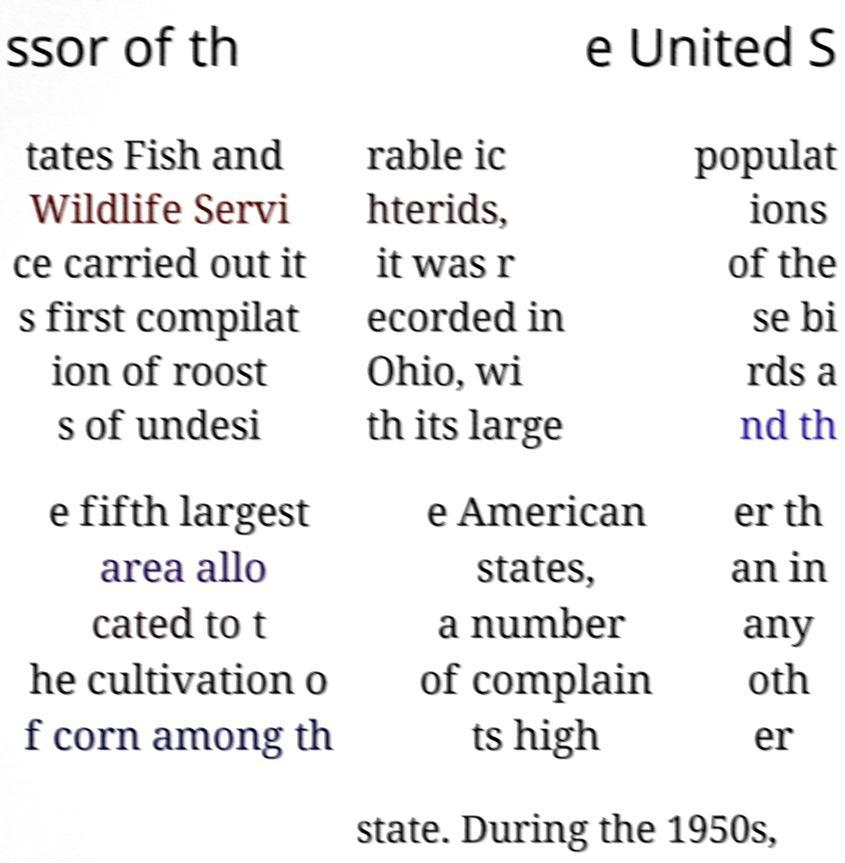Could you extract and type out the text from this image? ssor of th e United S tates Fish and Wildlife Servi ce carried out it s first compilat ion of roost s of undesi rable ic hterids, it was r ecorded in Ohio, wi th its large populat ions of the se bi rds a nd th e fifth largest area allo cated to t he cultivation o f corn among th e American states, a number of complain ts high er th an in any oth er state. During the 1950s, 